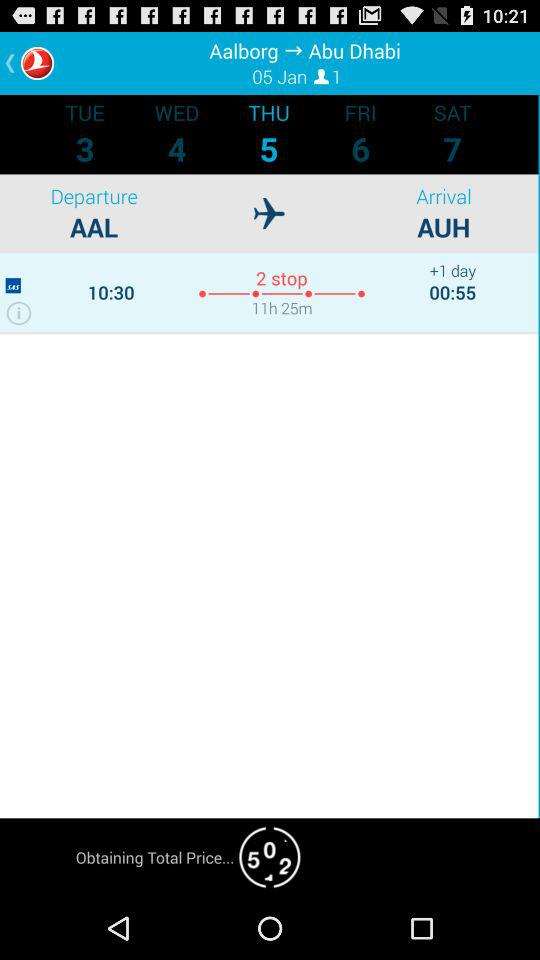Which date is selected? The selected date is January 5. 